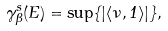<formula> <loc_0><loc_0><loc_500><loc_500>\gamma _ { \Theta } ^ { s } ( E ) = \sup \{ | \langle \nu , 1 \rangle | \} ,</formula> 